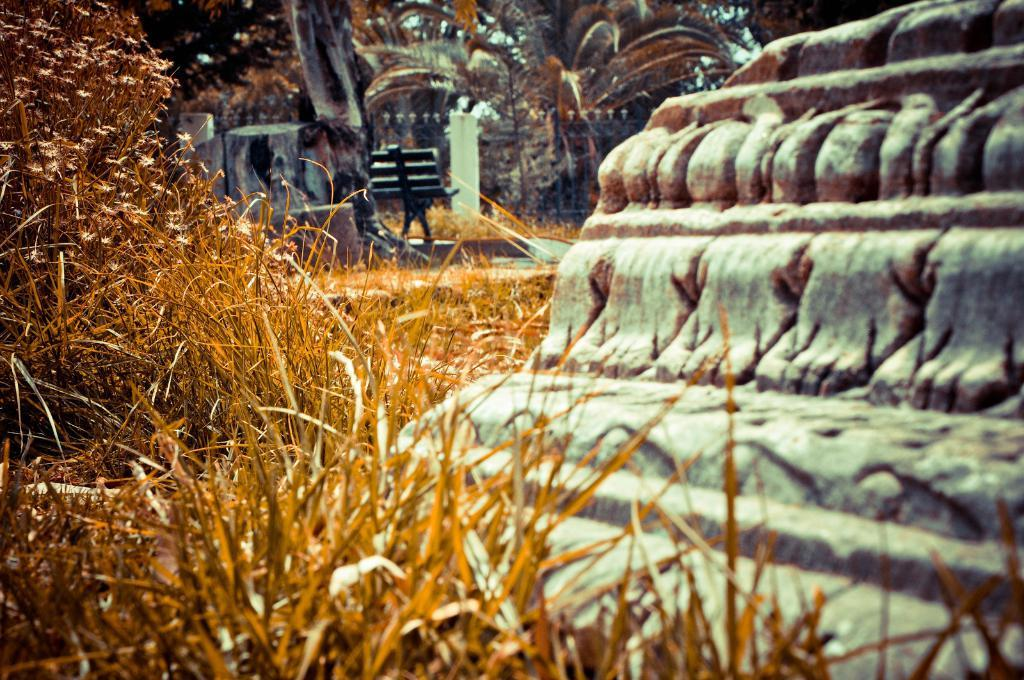What type of vegetation is present in the image? There is dry grass in the image. Are there any other natural elements in the image? Yes, there are trees in the image. What is located in front of the dry grass? There is a concrete structure in front of the grass. What can be seen in the background of the image? There are trees, a metal rod fence, and a bench in the background of the image. Can you tell me how many umbrellas are open in the field in the image? There is no field or umbrellas present in the image; it features dry grass, trees, and a concrete structure. What type of creature is using the rake in the image? There is no creature or rake present in the image. 